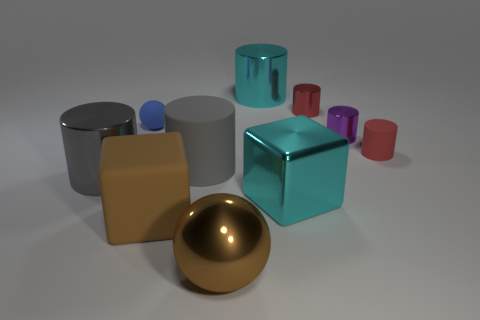Subtract all cyan shiny cylinders. How many cylinders are left? 5 Subtract all purple cylinders. How many cylinders are left? 5 Subtract all brown blocks. Subtract all red balls. How many blocks are left? 1 Subtract all purple blocks. How many red cylinders are left? 2 Add 10 big purple cylinders. How many big purple cylinders exist? 10 Subtract 0 brown cylinders. How many objects are left? 10 Subtract all blocks. How many objects are left? 8 Subtract 4 cylinders. How many cylinders are left? 2 Subtract all blue rubber spheres. Subtract all metal things. How many objects are left? 3 Add 3 brown shiny objects. How many brown shiny objects are left? 4 